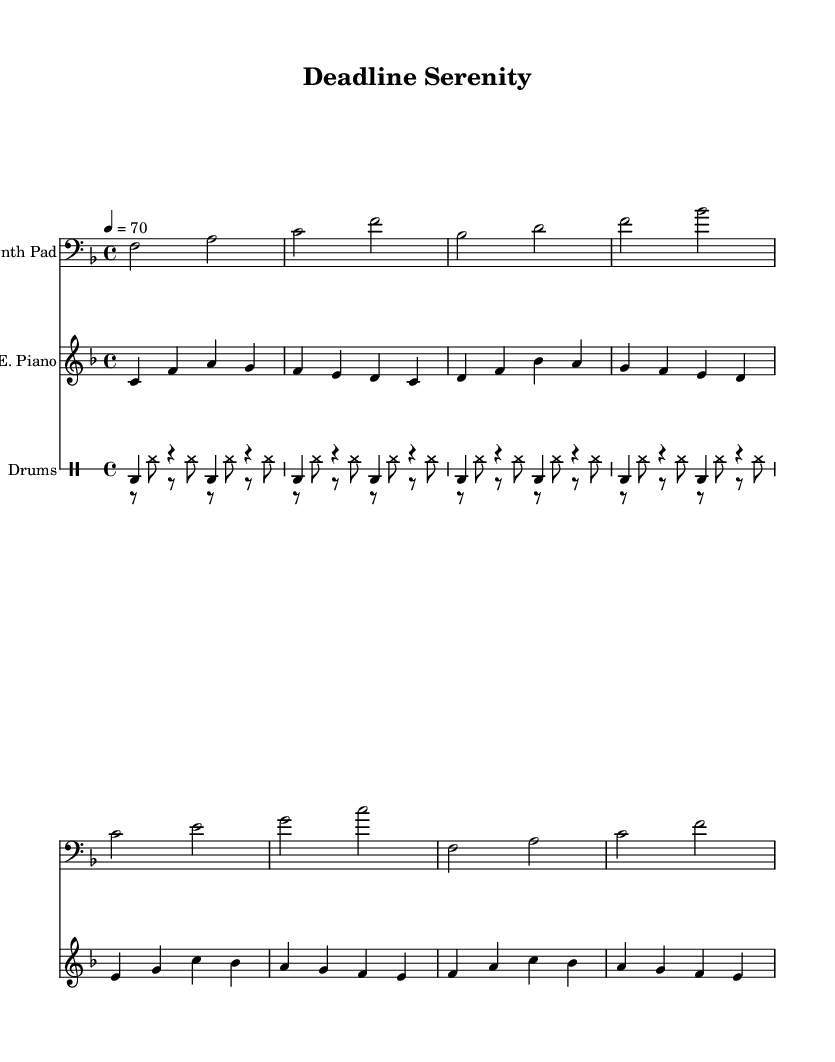What is the key signature of this music? The key signature indicated at the beginning of the piece shows that there is one flat, which corresponds to F major.
Answer: F major What is the time signature of this music? The time signature shown at the beginning of the score is four beats per measure, as indicated by 4/4.
Answer: 4/4 What is the tempo marking for this piece? The tempo marking is given as "4 = 70," meaning the piece should be played at 70 beats per minute.
Answer: 70 How many measures are in the synth pad part? The synth pad section consists of four measures, as indicated by the grouping in the score.
Answer: 4 Which instrument plays the bass clef? The bass clef is utilized in the synth pad part, identifying it as the instrument that plays lower tones.
Answer: Synth Pad How many different instruments are used in this score? The score features three distinct instruments, namely the synth pad, electric piano, and drum components.
Answer: 3 What type of rhythm does the hi-hat play? The hi-hat plays a steady eighth-note rhythm throughout its section, creating a consistent pulse.
Answer: Eighth-note 